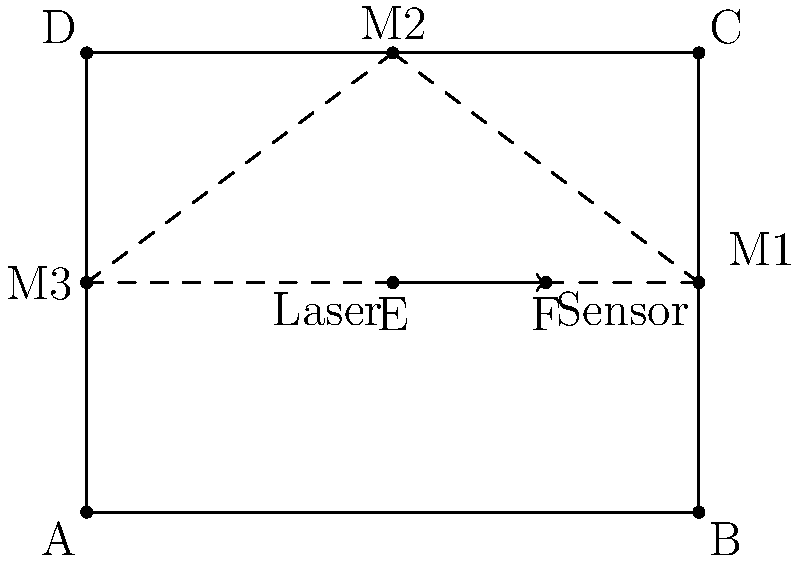In a robotics project, you're designing a laser-based object detection system. The laser sensor emits a beam from point E to point F, which then reflects off mirrors at points M1, M2, and M3 before returning to the sensor at point E. If the rectangle ABCD represents the robot's environment with dimensions 4 units wide and 3 units tall, what is the total distance traveled by the laser beam? To solve this problem, we need to calculate the total distance traveled by the laser beam as it reflects off the mirrors. Let's break it down step-by-step:

1) First, we need to identify the coordinates of all points:
   E(2, 1.5), F(3, 1.5), M1(4, 1.5), M2(2, 3), M3(0, 1.5)

2) Now, we'll calculate the distance between each pair of points using the distance formula:
   $d = \sqrt{(x_2-x_1)^2 + (y_2-y_1)^2}$

3) Distance from E to F:
   $EF = \sqrt{(3-2)^2 + (1.5-1.5)^2} = 1$ unit

4) Distance from F to M1:
   $FM1 = \sqrt{(4-3)^2 + (1.5-1.5)^2} = 1$ unit

5) Distance from M1 to M2:
   $M1M2 = \sqrt{(2-4)^2 + (3-1.5)^2} = \sqrt{4 + 2.25} = \sqrt{6.25} = 2.5$ units

6) Distance from M2 to M3:
   $M2M3 = \sqrt{(0-2)^2 + (1.5-3)^2} = \sqrt{4 + 2.25} = \sqrt{6.25} = 2.5$ units

7) Distance from M3 back to E:
   $M3E = \sqrt{(2-0)^2 + (1.5-1.5)^2} = 2$ units

8) Total distance is the sum of all these segments:
   Total = EF + FM1 + M1M2 + M2M3 + M3E
   Total = 1 + 1 + 2.5 + 2.5 + 2 = 9 units

Therefore, the total distance traveled by the laser beam is 9 units.
Answer: 9 units 